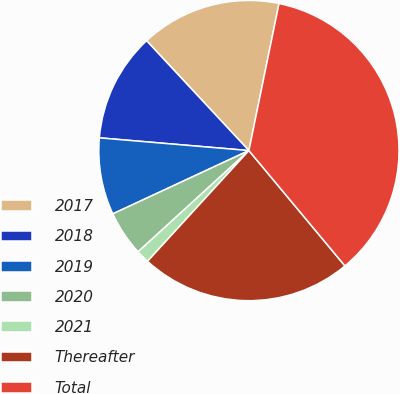Convert chart. <chart><loc_0><loc_0><loc_500><loc_500><pie_chart><fcel>2017<fcel>2018<fcel>2019<fcel>2020<fcel>2021<fcel>Thereafter<fcel>Total<nl><fcel>15.15%<fcel>11.71%<fcel>8.28%<fcel>4.85%<fcel>1.42%<fcel>22.85%<fcel>35.73%<nl></chart> 